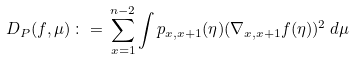<formula> <loc_0><loc_0><loc_500><loc_500>D _ { P } ( f , \mu ) \, \colon = \, \sum _ { x = 1 } ^ { n - 2 } \int p _ { x , x + 1 } ( \eta ) ( \nabla _ { x , x + 1 } f ( \eta ) ) ^ { 2 } \, d \mu</formula> 